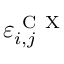<formula> <loc_0><loc_0><loc_500><loc_500>\varepsilon _ { i , j } ^ { C X }</formula> 